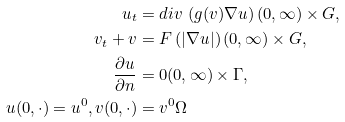Convert formula to latex. <formula><loc_0><loc_0><loc_500><loc_500>u _ { t } & = d i v \, \left ( g ( v ) \nabla u \right ) ( 0 , \infty ) \times G , \\ v _ { t } + v & = F \left ( | \nabla u | \right ) ( 0 , \infty ) \times G , \\ \frac { \partial u } { \partial n } & = 0 ( 0 , \infty ) \times \Gamma , \\ u ( 0 , \cdot ) = u ^ { 0 } , v ( 0 , \cdot ) & = v ^ { 0 } \Omega</formula> 